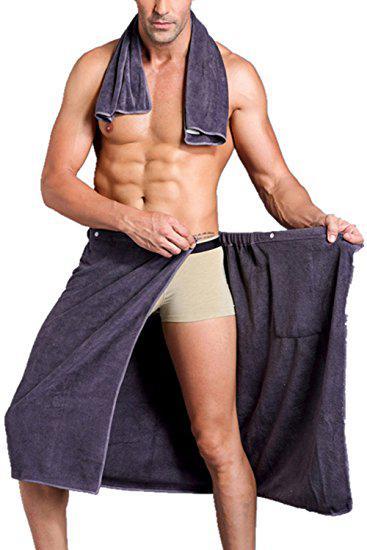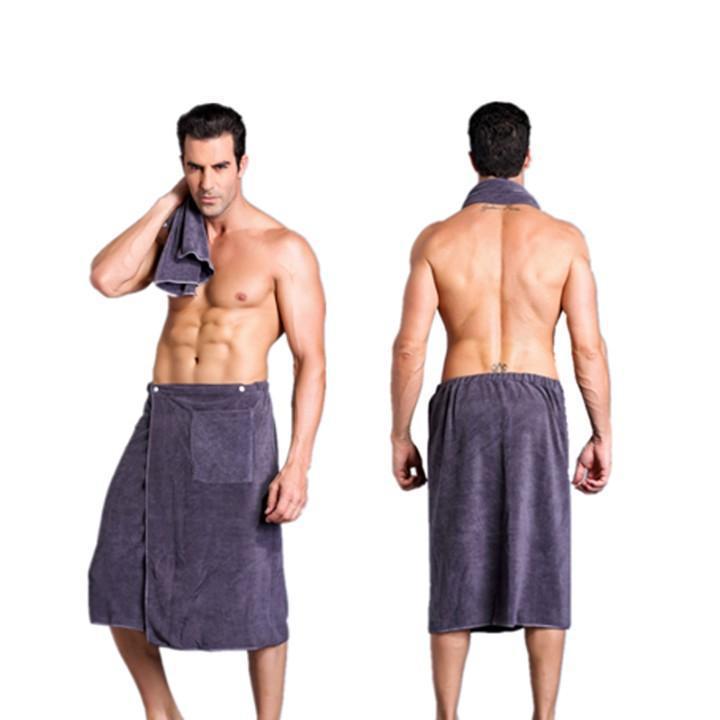The first image is the image on the left, the second image is the image on the right. Considering the images on both sides, is "Every photo shows exactly one shirtless man modeling one towel around his waist and the towels are not the same color." valid? Answer yes or no. No. The first image is the image on the left, the second image is the image on the right. Evaluate the accuracy of this statement regarding the images: "Each image shows one dark-haired man, who faces forward, wearing only a towel wrapped around his waist, and one image features a man wearing a white towel.". Is it true? Answer yes or no. No. 